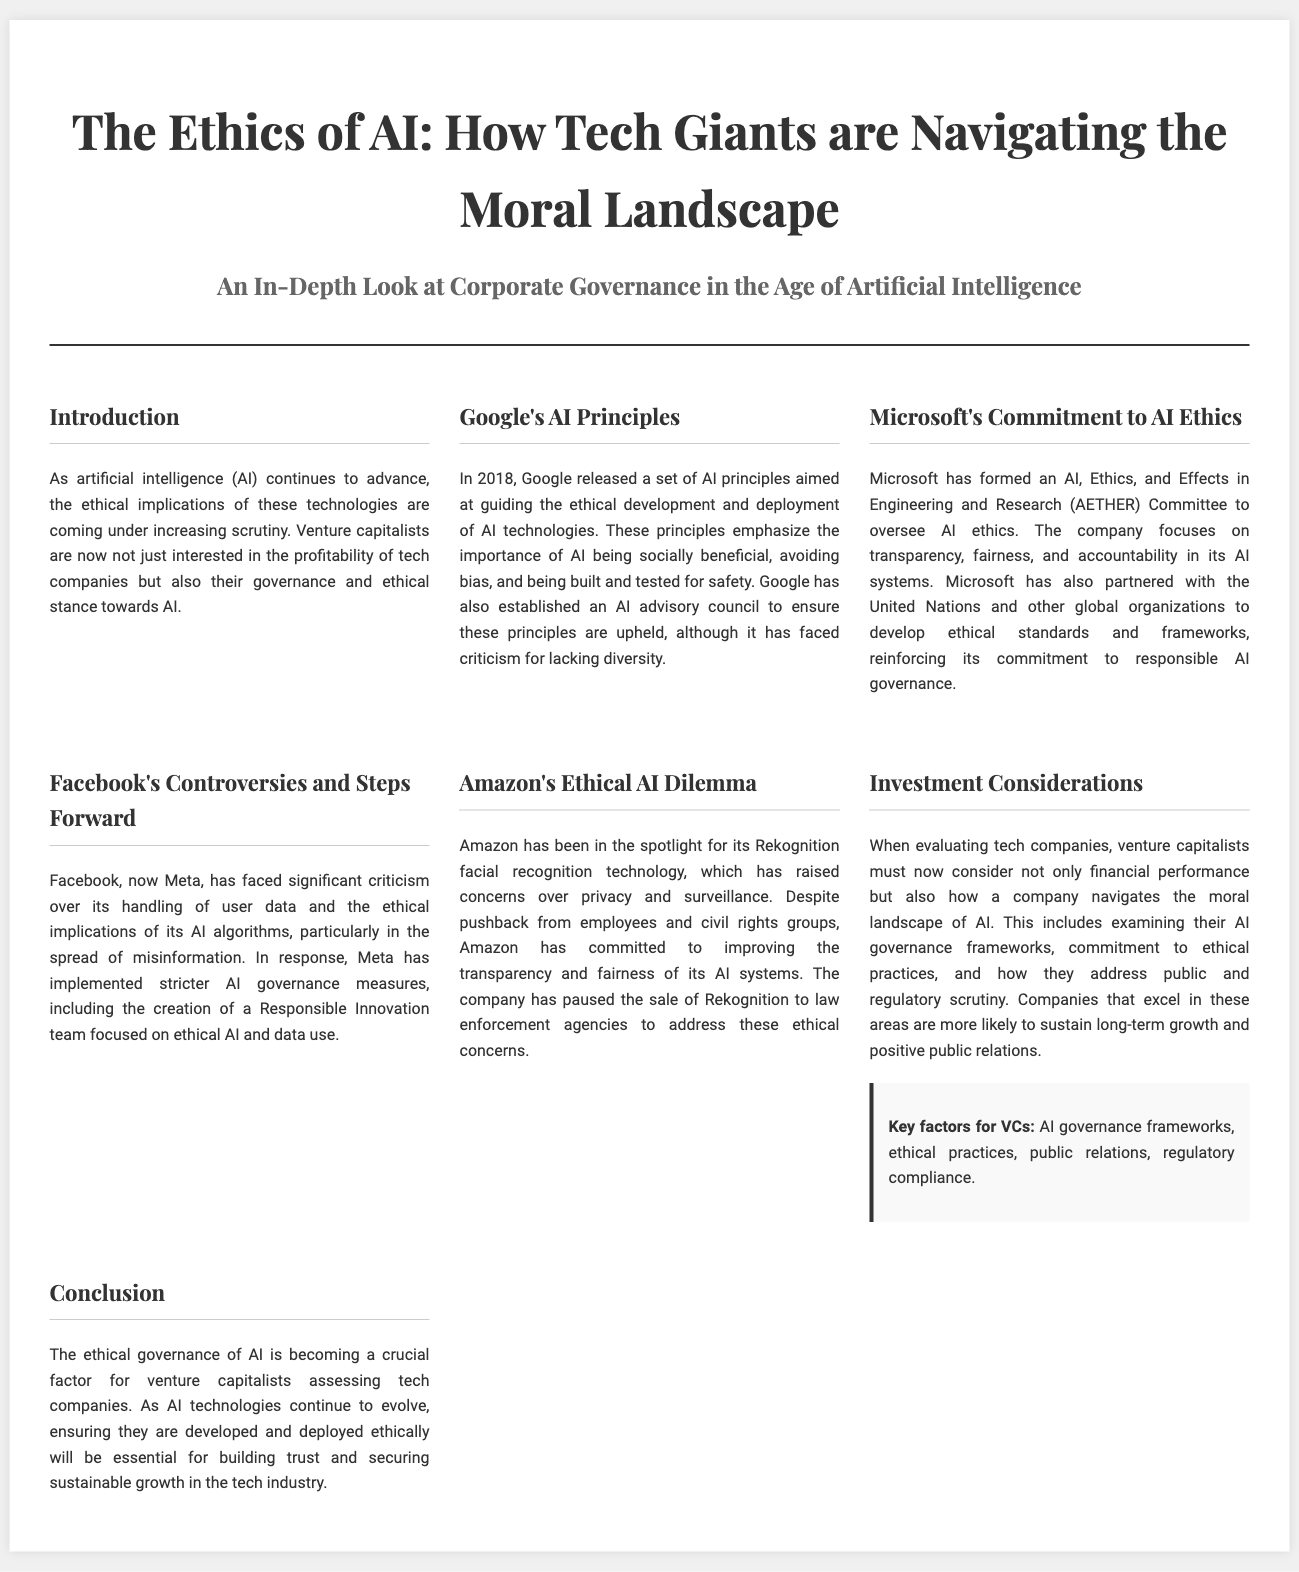What year did Google release its AI principles? The document states that Google released its AI principles in 2018.
Answer: 2018 What committee has Microsoft formed for overseeing AI ethics? The document mentions that Microsoft formed the AETHER Committee for AI ethics oversight.
Answer: AETHER Committee What has Facebook implemented in response to ethical criticisms? According to the document, Facebook has implemented stricter AI governance measures, including the Responsible Innovation team.
Answer: Responsible Innovation team Which company has faced scrutiny over its Rekognition technology? The document identifies Amazon as the company facing scrutiny over its Rekognition facial recognition technology.
Answer: Amazon What is a key factor for VCs when evaluating tech companies? The document highlights AI governance frameworks as a key factor for venture capitalists.
Answer: AI governance frameworks Why is ethical governance of AI crucial for venture capitalists? The document explains that ethical governance is essential for building trust and securing sustainable growth in the tech industry.
Answer: Building trust and securing sustainable growth What overarching theme does the document focus on? The document focuses on the ethical implications of AI technologies in relation to corporate governance.
Answer: Ethical implications of AI technologies What does Microsoft's partnership with global organizations aim to develop? The document states that Microsoft’s partnership aims to develop ethical standards and frameworks for AI.
Answer: Ethical standards and frameworks 